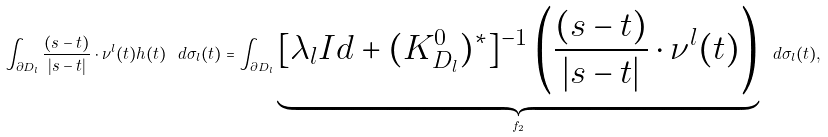Convert formula to latex. <formula><loc_0><loc_0><loc_500><loc_500>\int _ { \partial D _ { l } } \frac { ( s - t ) } { | s - t | } \cdot \nu ^ { l } ( t ) h ( t ) \ d \sigma _ { l } ( t ) = \int _ { \partial D _ { l } } \underbrace { [ \lambda _ { l } I d + ( K ^ { 0 } _ { D _ { l } } ) ^ { * } ] ^ { - 1 } \left ( \frac { ( s - t ) } { | s - t | } \cdot \nu ^ { l } ( t ) \right ) } _ { f _ { 2 } } \ d \sigma _ { l } ( t ) ,</formula> 